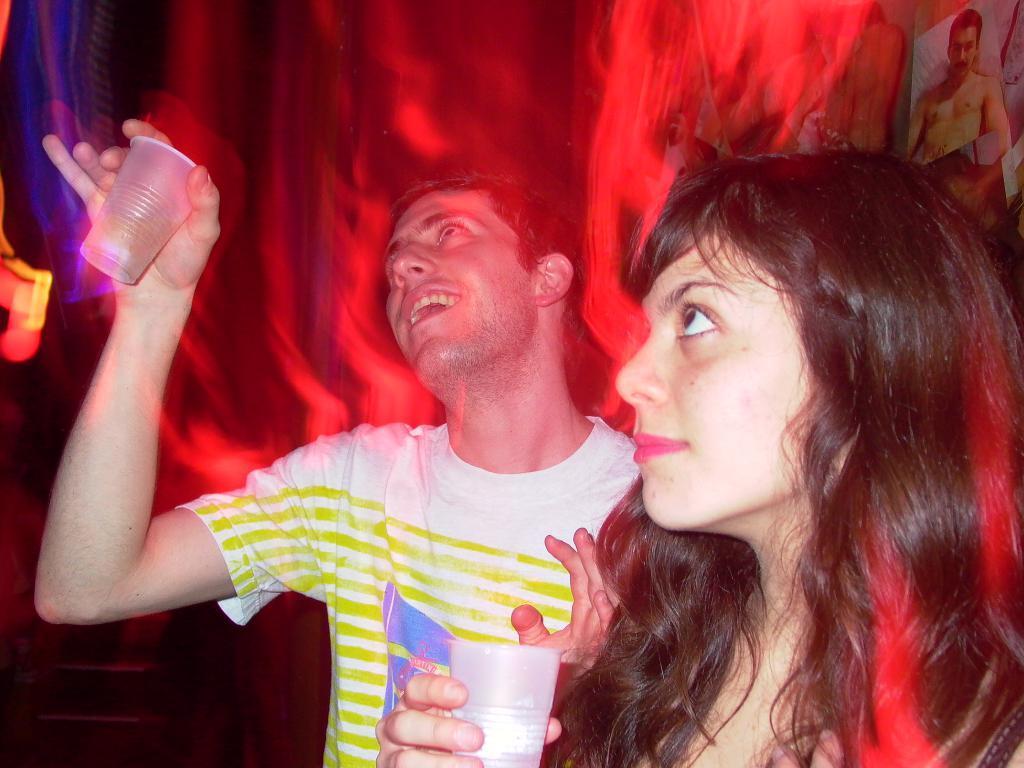How would you summarize this image in a sentence or two? In this image, we can see people holding glasses with their hands. There is a photo in the top right of the image. 